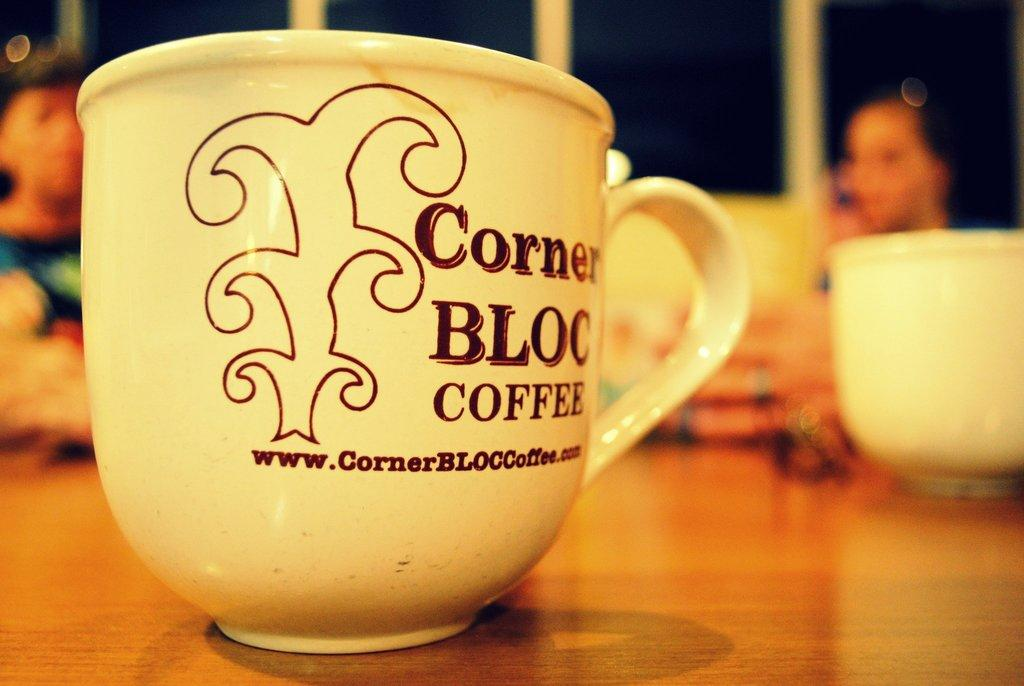What is on the table in the image? There is a coffee cup on the table in the image. Where is the coffee cup located in relation to the table? The coffee cup is on the table in the image. Can you describe the background of the image? There are people in the background of the image. What type of basket is being used for the action in the image? There is no basket or action present in the image; it features a coffee cup on a table with people in the background. 